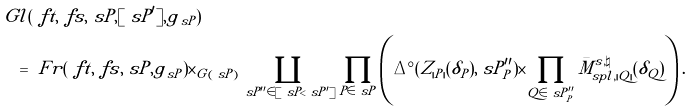Convert formula to latex. <formula><loc_0><loc_0><loc_500><loc_500>{ } & \ G l ( \ f t , \ f s , \ s P , [ \ s P ^ { \prime } ] , g _ { \ s P } ) \\ & \quad = \ F r ( \ f t , \ f s , \ s P , g _ { \ s P } ) \times _ { G ( \ s P ) } \coprod _ { \ s P ^ { \prime \prime } \in [ \ s P < \ s P ^ { \prime } ] } \prod _ { P \in \ s P } \left ( \Delta ^ { \circ } ( Z _ { | P | } ( \delta _ { P } ) , \ s P ^ { \prime \prime } _ { P } ) \times \prod _ { Q \in \ s P ^ { \prime \prime } _ { P } } \bar { M } ^ { s , \natural } _ { s p l , | Q | } ( \delta _ { Q } ) \right ) .</formula> 